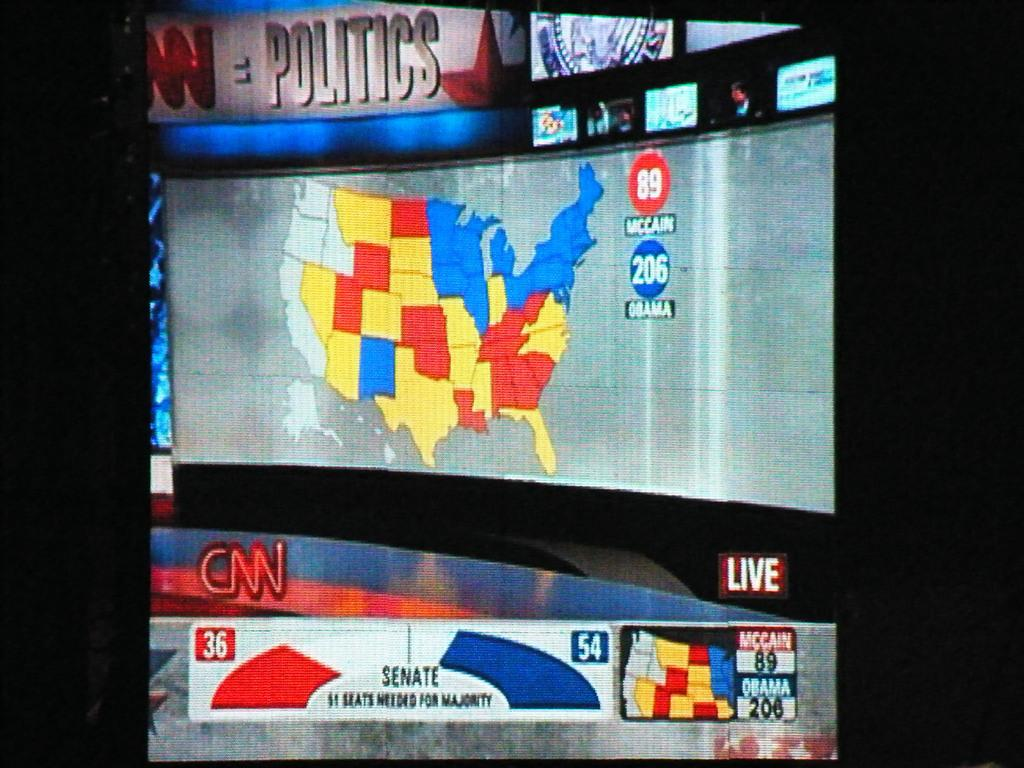Provide a one-sentence caption for the provided image. a screenshot from CNN about a Senate Politics New Jersey state map. 